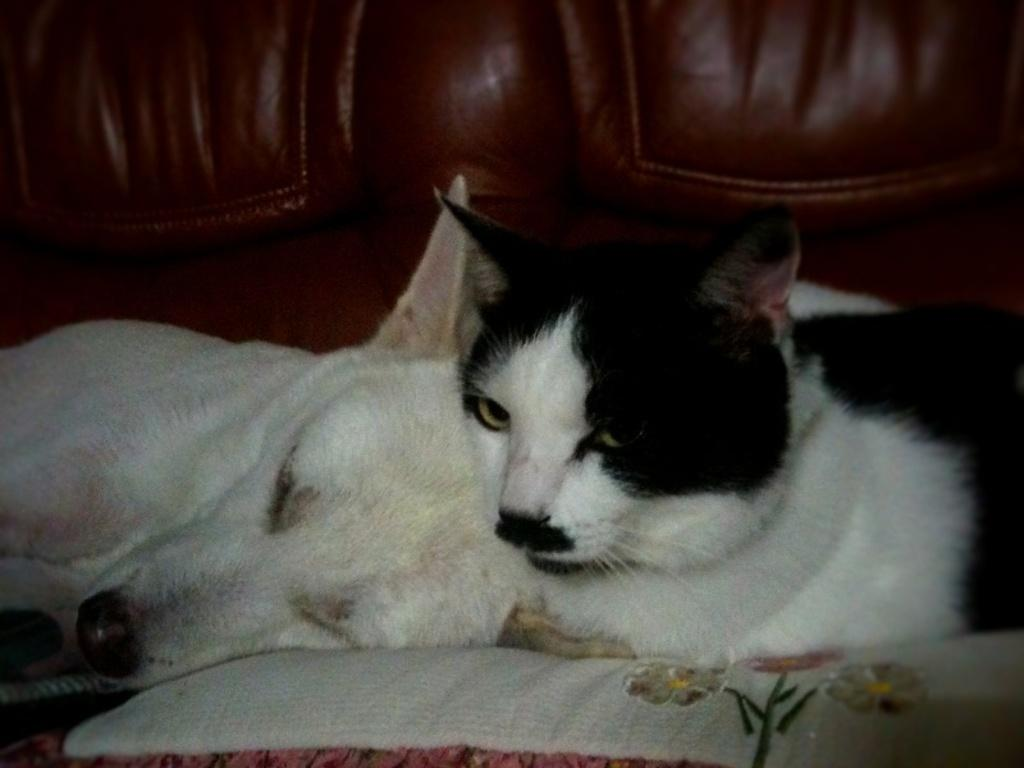What type of furniture is present in the image? There is a couch in the image. What animal can be seen on the couch? There is a dog on the couch. Are there any other animals present on the couch? Yes, there is a cat on the couch. What type of flag is visible on the couch in the image? There is no flag present on the couch in the image. What type of voice can be heard coming from the dog in the image? The image is a still image, so no sound or voice can be heard. 